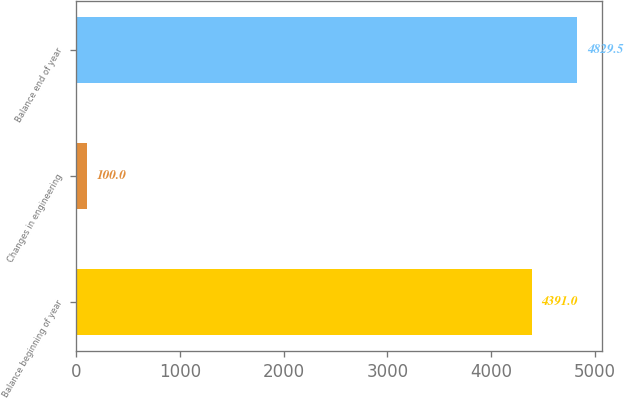Convert chart. <chart><loc_0><loc_0><loc_500><loc_500><bar_chart><fcel>Balance beginning of year<fcel>Changes in engineering<fcel>Balance end of year<nl><fcel>4391<fcel>100<fcel>4829.5<nl></chart> 